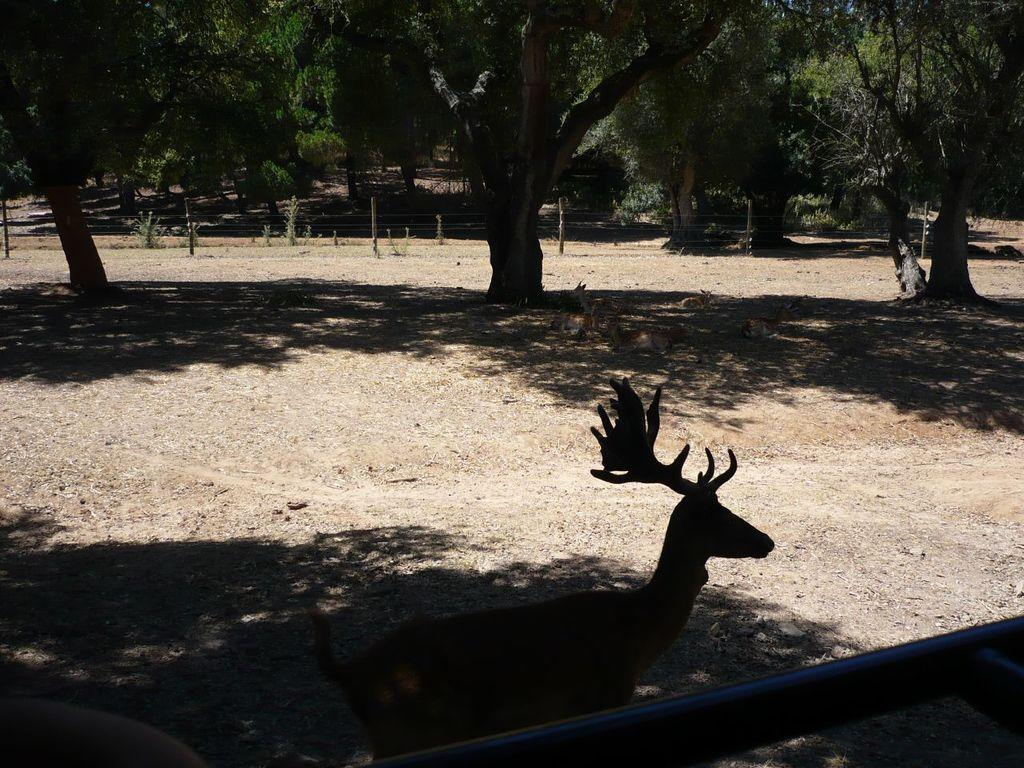Where was the image taken? The image is clicked outside. What animal can be seen in the image? There is a deer standing on the ground in the image. What is visible at the bottom of the image? The ground is visible at the bottom of the image. What can be seen in the background of the image? There are trees in the background of the image. How many cats are sleeping on the beds in the image? There are no beds or cats present in the image. 